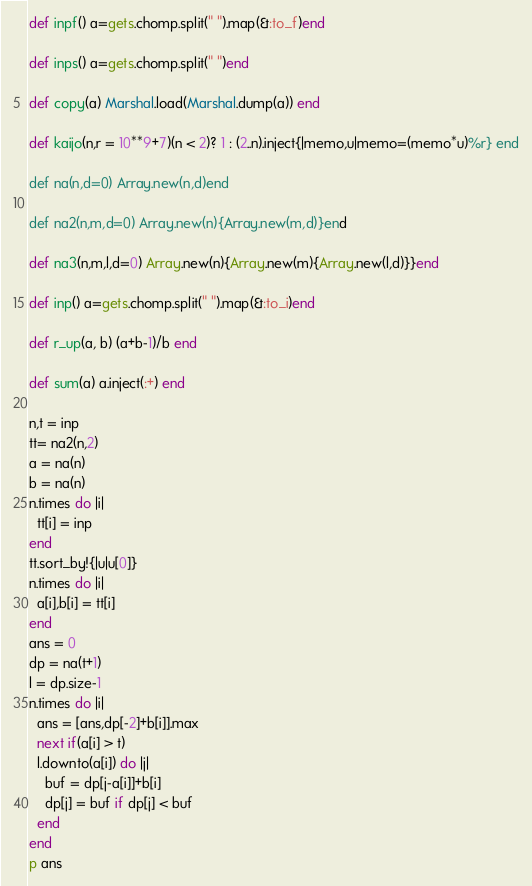<code> <loc_0><loc_0><loc_500><loc_500><_Ruby_>def inpf() a=gets.chomp.split(" ").map(&:to_f)end

def inps() a=gets.chomp.split(" ")end

def copy(a) Marshal.load(Marshal.dump(a)) end

def kaijo(n,r = 10**9+7)(n < 2)? 1 : (2..n).inject{|memo,u|memo=(memo*u)%r} end

def na(n,d=0) Array.new(n,d)end

def na2(n,m,d=0) Array.new(n){Array.new(m,d)}end

def na3(n,m,l,d=0) Array.new(n){Array.new(m){Array.new(l,d)}}end

def inp() a=gets.chomp.split(" ").map(&:to_i)end

def r_up(a, b) (a+b-1)/b end

def sum(a) a.inject(:+) end

n,t = inp
tt= na2(n,2)
a = na(n)
b = na(n)
n.times do |i|
  tt[i] = inp
end
tt.sort_by!{|u|u[0]}
n.times do |i|
  a[i],b[i] = tt[i]
end
ans = 0
dp = na(t+1)
l = dp.size-1
n.times do |i|
  ans = [ans,dp[-2]+b[i]].max
  next if(a[i] > t)
  l.downto(a[i]) do |j|
    buf = dp[j-a[i]]+b[i]
    dp[j] = buf if dp[j] < buf
  end
end
p ans</code> 